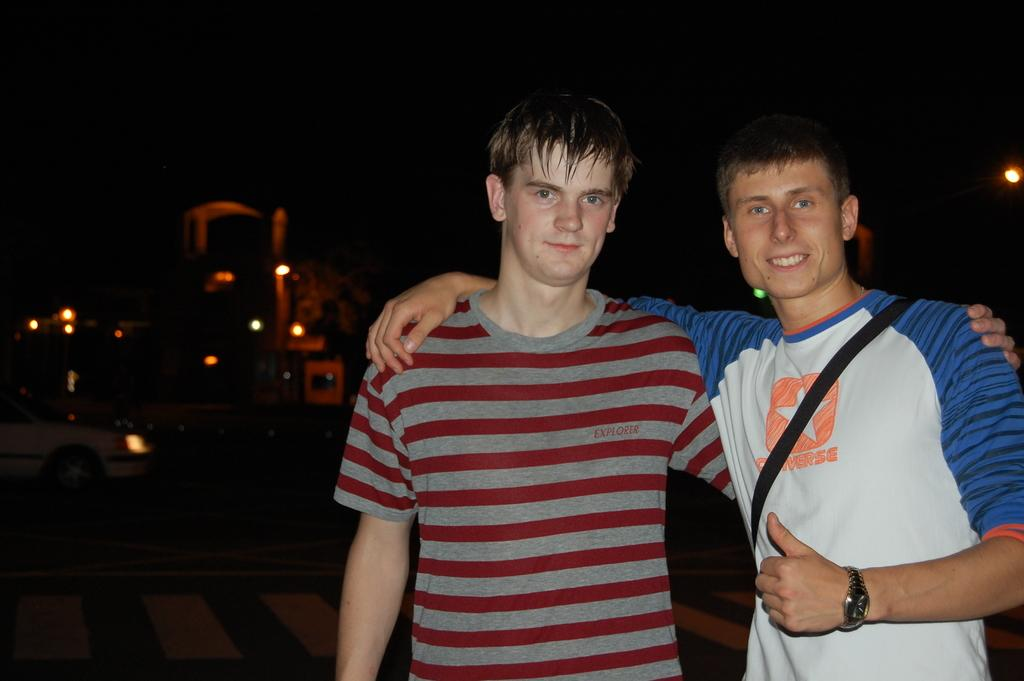<image>
Present a compact description of the photo's key features. the man on the right is wearing a Converse tshirt 